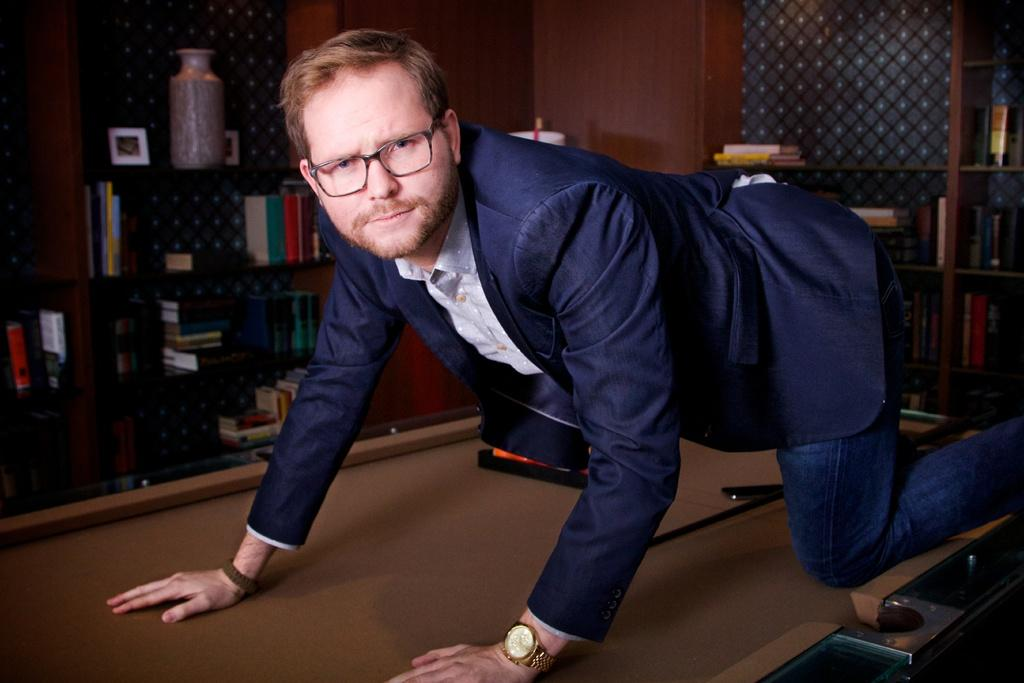What is the person in the image doing? The person is in the crawling position on a table. What can be seen behind the person? There are bookshelves behind the person. What type of wilderness can be seen in the background of the image? There is no wilderness present in the image; it features a person crawling on a table with bookshelves in the background. 